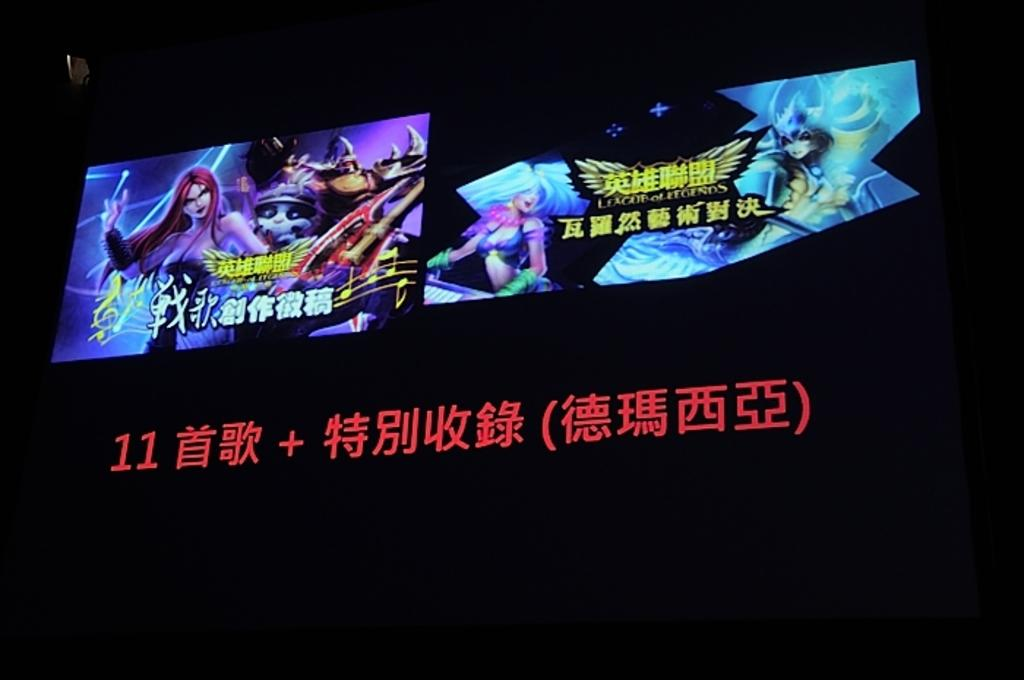What is the main object in the center of the image? There is a screen in the center of the image. What is displayed on the screen? Animations are present on the screen, along with Chinese script. Is there any text visible at the bottom of the image? Yes, there is Chinese text at the bottom of the image. What is the color of the background in the image? The background of the image is black. Can you tell me how many writers are visible in the image? There are no writers present in the image. What type of eye can be seen in the image? There is no eye visible in the image. 